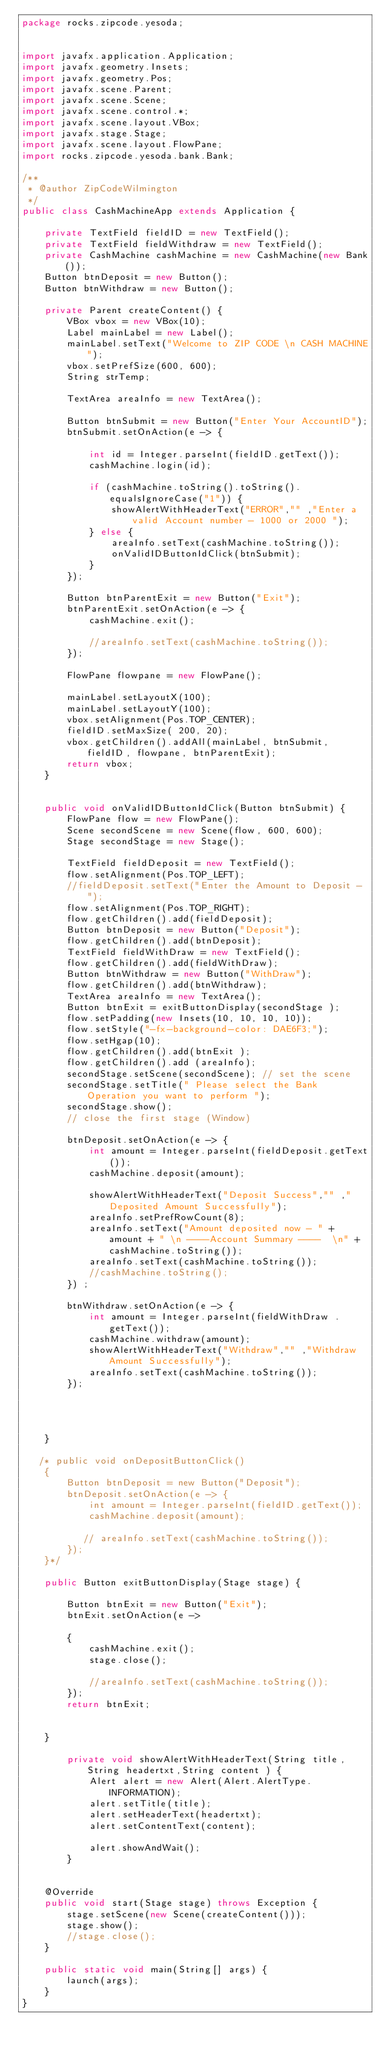<code> <loc_0><loc_0><loc_500><loc_500><_Java_>package rocks.zipcode.yesoda;


import javafx.application.Application;
import javafx.geometry.Insets;
import javafx.geometry.Pos;
import javafx.scene.Parent;
import javafx.scene.Scene;
import javafx.scene.control.*;
import javafx.scene.layout.VBox;
import javafx.stage.Stage;
import javafx.scene.layout.FlowPane;
import rocks.zipcode.yesoda.bank.Bank;

/**
 * @author ZipCodeWilmington
 */
public class CashMachineApp extends Application {

    private TextField fieldID = new TextField();
    private TextField fieldWithdraw = new TextField();
    private CashMachine cashMachine = new CashMachine(new Bank());
    Button btnDeposit = new Button();
    Button btnWithdraw = new Button();

    private Parent createContent() {
        VBox vbox = new VBox(10);
        Label mainLabel = new Label();
        mainLabel.setText("Welcome to ZIP CODE \n CASH MACHINE");
        vbox.setPrefSize(600, 600);
        String strTemp;

        TextArea areaInfo = new TextArea();

        Button btnSubmit = new Button("Enter Your AccountID");
        btnSubmit.setOnAction(e -> {

            int id = Integer.parseInt(fieldID.getText());
            cashMachine.login(id);

            if (cashMachine.toString().toString().equalsIgnoreCase("1")) {
                showAlertWithHeaderText("ERROR","" ,"Enter a valid Account number - 1000 or 2000 ");
            } else {
                areaInfo.setText(cashMachine.toString());
                onValidIDButtonIdClick(btnSubmit);
            }
        });

        Button btnParentExit = new Button("Exit");
        btnParentExit.setOnAction(e -> {
            cashMachine.exit();

            //areaInfo.setText(cashMachine.toString());
        });

        FlowPane flowpane = new FlowPane();

        mainLabel.setLayoutX(100);
        mainLabel.setLayoutY(100);
        vbox.setAlignment(Pos.TOP_CENTER);
        fieldID.setMaxSize( 200, 20);
        vbox.getChildren().addAll(mainLabel, btnSubmit, fieldID, flowpane, btnParentExit);
        return vbox;
    }


    public void onValidIDButtonIdClick(Button btnSubmit) {
        FlowPane flow = new FlowPane();
        Scene secondScene = new Scene(flow, 600, 600);
        Stage secondStage = new Stage();

        TextField fieldDeposit = new TextField();
        flow.setAlignment(Pos.TOP_LEFT);
        //fieldDeposit.setText("Enter the Amount to Deposit - ");
        flow.setAlignment(Pos.TOP_RIGHT);
        flow.getChildren().add(fieldDeposit);
        Button btnDeposit = new Button("Deposit");
        flow.getChildren().add(btnDeposit);
        TextField fieldWithDraw = new TextField();
        flow.getChildren().add(fieldWithDraw);
        Button btnWithdraw = new Button("WithDraw");
        flow.getChildren().add(btnWithdraw);
        TextArea areaInfo = new TextArea();
        Button btnExit = exitButtonDisplay(secondStage );
        flow.setPadding(new Insets(10, 10, 10, 10));
        flow.setStyle("-fx-background-color: DAE6F3;");
        flow.setHgap(10);
        flow.getChildren().add(btnExit );
        flow.getChildren().add (areaInfo);
        secondStage.setScene(secondScene); // set the scene
        secondStage.setTitle(" Please select the Bank Operation you want to perform ");
        secondStage.show();
        // close the first stage (Window)

        btnDeposit.setOnAction(e -> {
            int amount = Integer.parseInt(fieldDeposit.getText());
            cashMachine.deposit(amount);

            showAlertWithHeaderText("Deposit Success","" ,"Deposited Amount Successfully");
            areaInfo.setPrefRowCount(8);
            areaInfo.setText("Amount deposited now - " + amount + " \n ----Account Summary ----  \n" + cashMachine.toString());
            areaInfo.setText(cashMachine.toString());
            //cashMachine.toString();
        }) ;

        btnWithdraw.setOnAction(e -> {
            int amount = Integer.parseInt(fieldWithDraw .getText());
            cashMachine.withdraw(amount);
            showAlertWithHeaderText("Withdraw","" ,"Withdraw Amount Successfully");
            areaInfo.setText(cashMachine.toString());
        });




    }

   /* public void onDepositButtonClick()
    {
        Button btnDeposit = new Button("Deposit");
        btnDeposit.setOnAction(e -> {
            int amount = Integer.parseInt(fieldID.getText());
            cashMachine.deposit(amount);

           // areaInfo.setText(cashMachine.toString());
        });
    }*/

    public Button exitButtonDisplay(Stage stage) {

        Button btnExit = new Button("Exit");
        btnExit.setOnAction(e ->

        {
            cashMachine.exit();
            stage.close();

            //areaInfo.setText(cashMachine.toString());
        });
        return btnExit;


    }

        private void showAlertWithHeaderText(String title,String headertxt,String content ) {
            Alert alert = new Alert(Alert.AlertType.INFORMATION);
            alert.setTitle(title);
            alert.setHeaderText(headertxt);
            alert.setContentText(content);

            alert.showAndWait();
        }


    @Override
    public void start(Stage stage) throws Exception {
        stage.setScene(new Scene(createContent()));
        stage.show();
        //stage.close();
    }

    public static void main(String[] args) {
        launch(args);
    }
}
</code> 